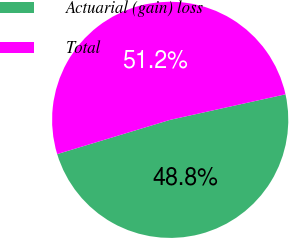<chart> <loc_0><loc_0><loc_500><loc_500><pie_chart><fcel>Actuarial (gain) loss<fcel>Total<nl><fcel>48.78%<fcel>51.22%<nl></chart> 